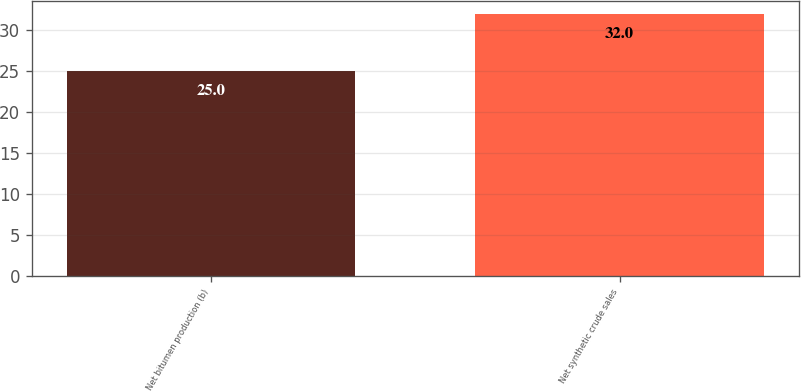<chart> <loc_0><loc_0><loc_500><loc_500><bar_chart><fcel>Net bitumen production (b)<fcel>Net synthetic crude sales<nl><fcel>25<fcel>32<nl></chart> 